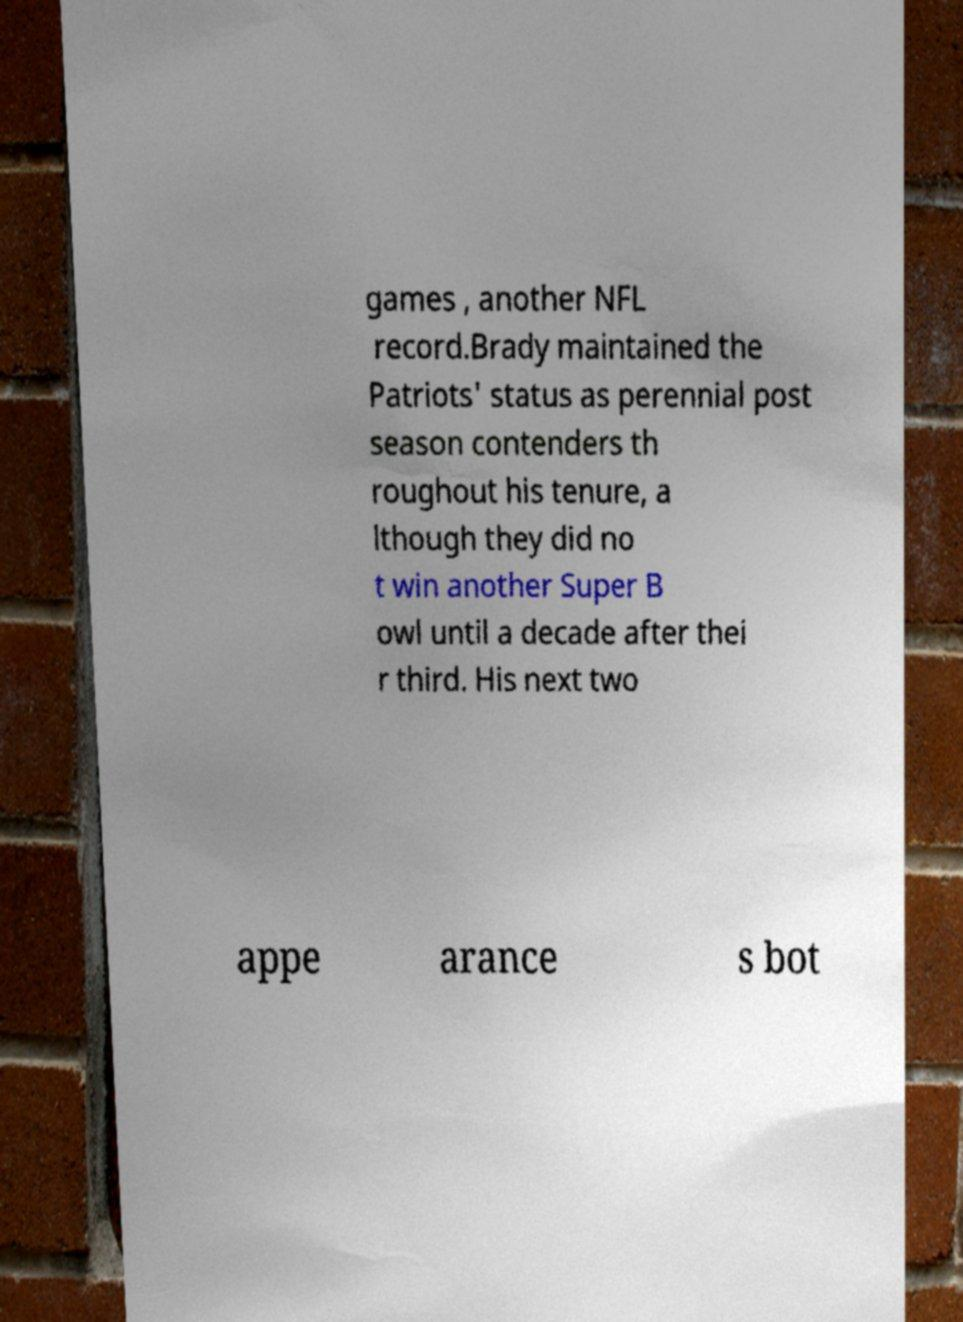Could you extract and type out the text from this image? games , another NFL record.Brady maintained the Patriots' status as perennial post season contenders th roughout his tenure, a lthough they did no t win another Super B owl until a decade after thei r third. His next two appe arance s bot 